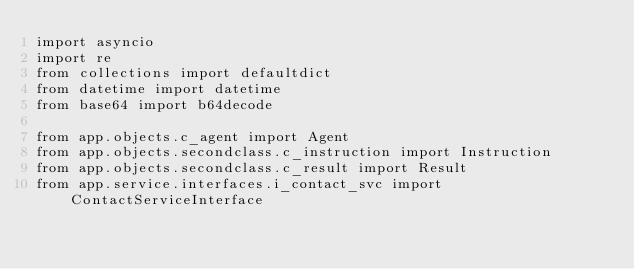<code> <loc_0><loc_0><loc_500><loc_500><_Python_>import asyncio
import re
from collections import defaultdict
from datetime import datetime
from base64 import b64decode

from app.objects.c_agent import Agent
from app.objects.secondclass.c_instruction import Instruction
from app.objects.secondclass.c_result import Result
from app.service.interfaces.i_contact_svc import ContactServiceInterface</code> 